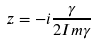<formula> <loc_0><loc_0><loc_500><loc_500>z = - i \frac { \gamma } { 2 I m \gamma }</formula> 